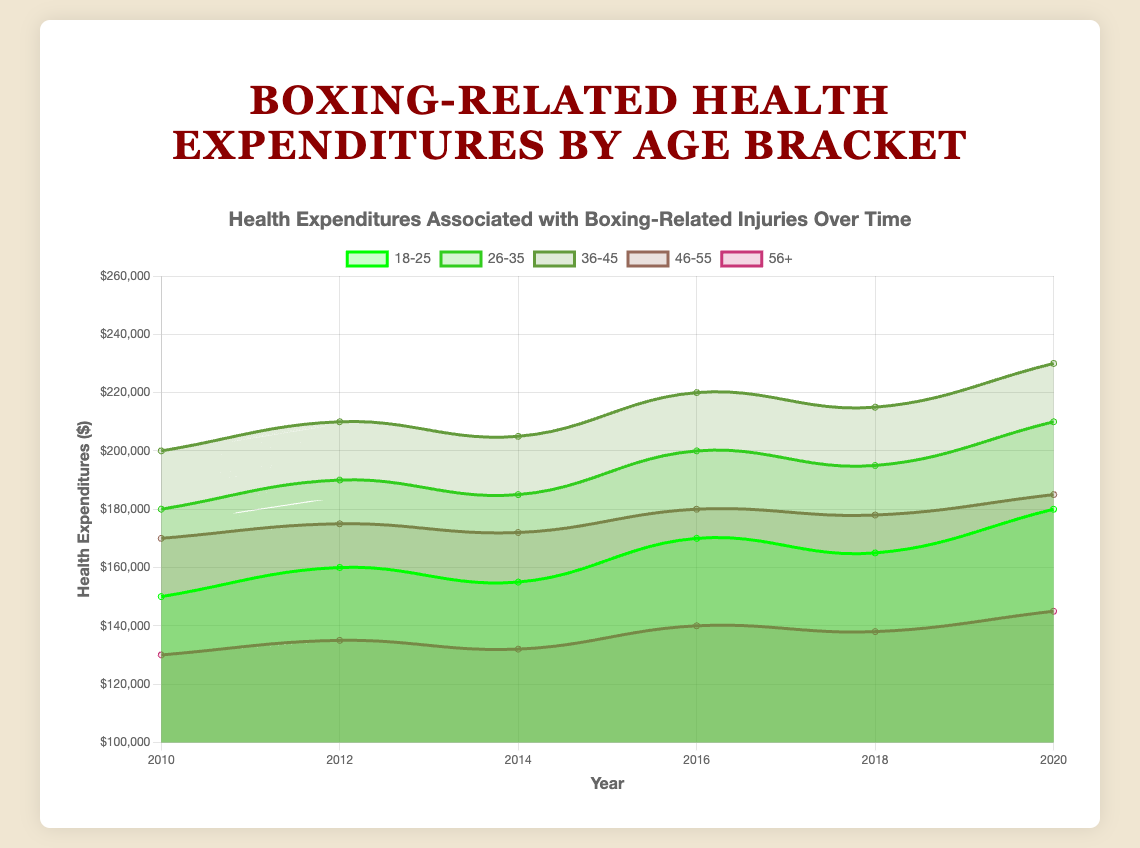What is the title of the chart? The title of the chart is located at the top center of the chart as a text description. By reading this text, we can determine the title.
Answer: Boxing-Related Health Expenditures by Age Bracket Which age bracket had the highest health expenditures in 2020? Look at the data points corresponding to the year 2020 for all age brackets and find the highest value. The age bracket "36-45" has the highest value at $230,000.
Answer: 36-45 How much did the health expenditures for the age bracket 26-35 increase from 2010 to 2020? Find the values for 26-35 in 2010 and 2020 from the chart, then subtract the 2010 value from the 2020 value: 210,000 - 180,000 = 30,000.
Answer: 30,000 Which age bracket had the lowest increase in health expenditures from 2010 to 2020? Calculate the increase for each age bracket from 2010 to 2020, then determine the lowest increase. For 18-25: 180,000 - 150,000 = 30,000. For 26-35: 210,000 - 180,000 = 30,000. For 36-45: 230,000 - 200,000 = 30,000. For 46-55: 185,000 - 170,000 = 15,000. For 56+: 145,000 - 130,000 = 15,000. The age brackets "46-55" and "56+" both have the lowest increase of $15,000.
Answer: 46-55 and 56+ In which year did the age bracket 36-45 see the steepest rise in health expenditures? Look at the slope of the line representing the 36-45 age bracket over the years and identify the year with the steepest incline. The steepest rise for 36-45 is between 2018 and 2020, with an increase from 215,000 to 230,000.
Answer: 2018-2020 What is the average health expenditure for the 46-55 age bracket over the given years? Sum the expenditure values for 46-55 (170,000 + 175,000 + 172,000 + 180,000 + 178,000 + 185,000) and divide by the number of years (6): (170,000 + 175,000 + 172,000 + 180,000 + 178,000 + 185,000) / 6 = 176,667.
Answer: 176,667 Do younger age brackets tend to have lower or higher health expenditures compared to older age brackets? Compare the general trend of expenditures by looking at the plotted data for younger age brackets (18-25, 26-35) versus older age brackets (36-45, 46-55, 56+). Older age brackets consistently have higher expenditures than younger ones across the years.
Answer: Higher How did health expenditures for the age bracket 18-25 change from 2012 to 2014? Compare the expenditure values for the 18-25 age bracket in 2012 and 2014. Subtract the 2014 value from the 2012 value: 155,000 - 160,000 = -5,000, indicating a decrease.
Answer: Decreased by 5,000 